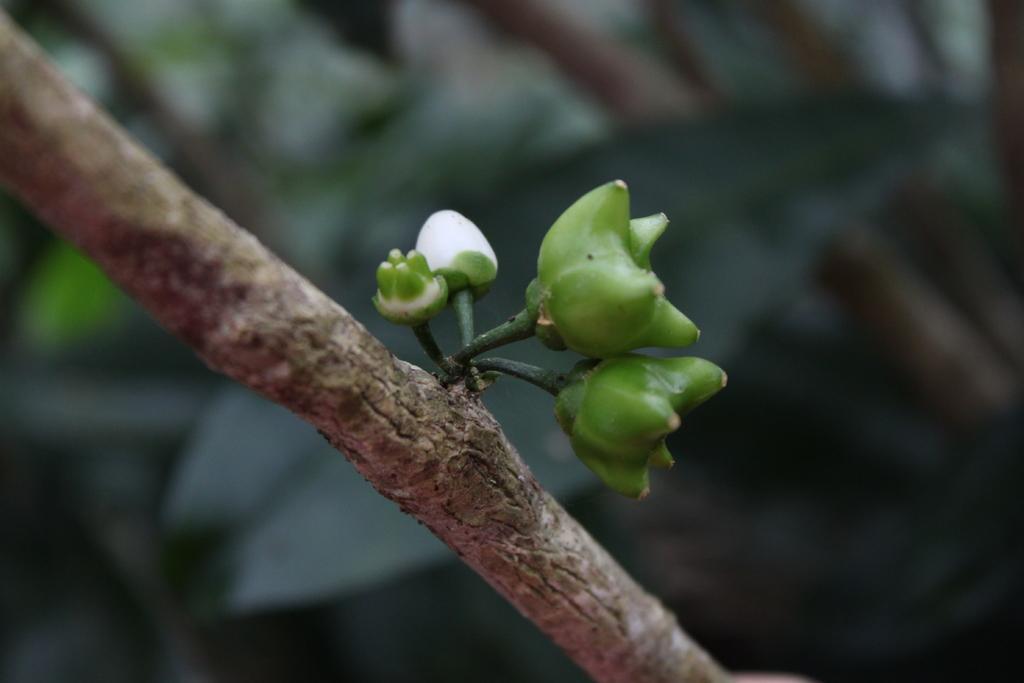Can you describe this image briefly? In this picture we can see the buds on the branch and behind the buds there is the blurred background. 